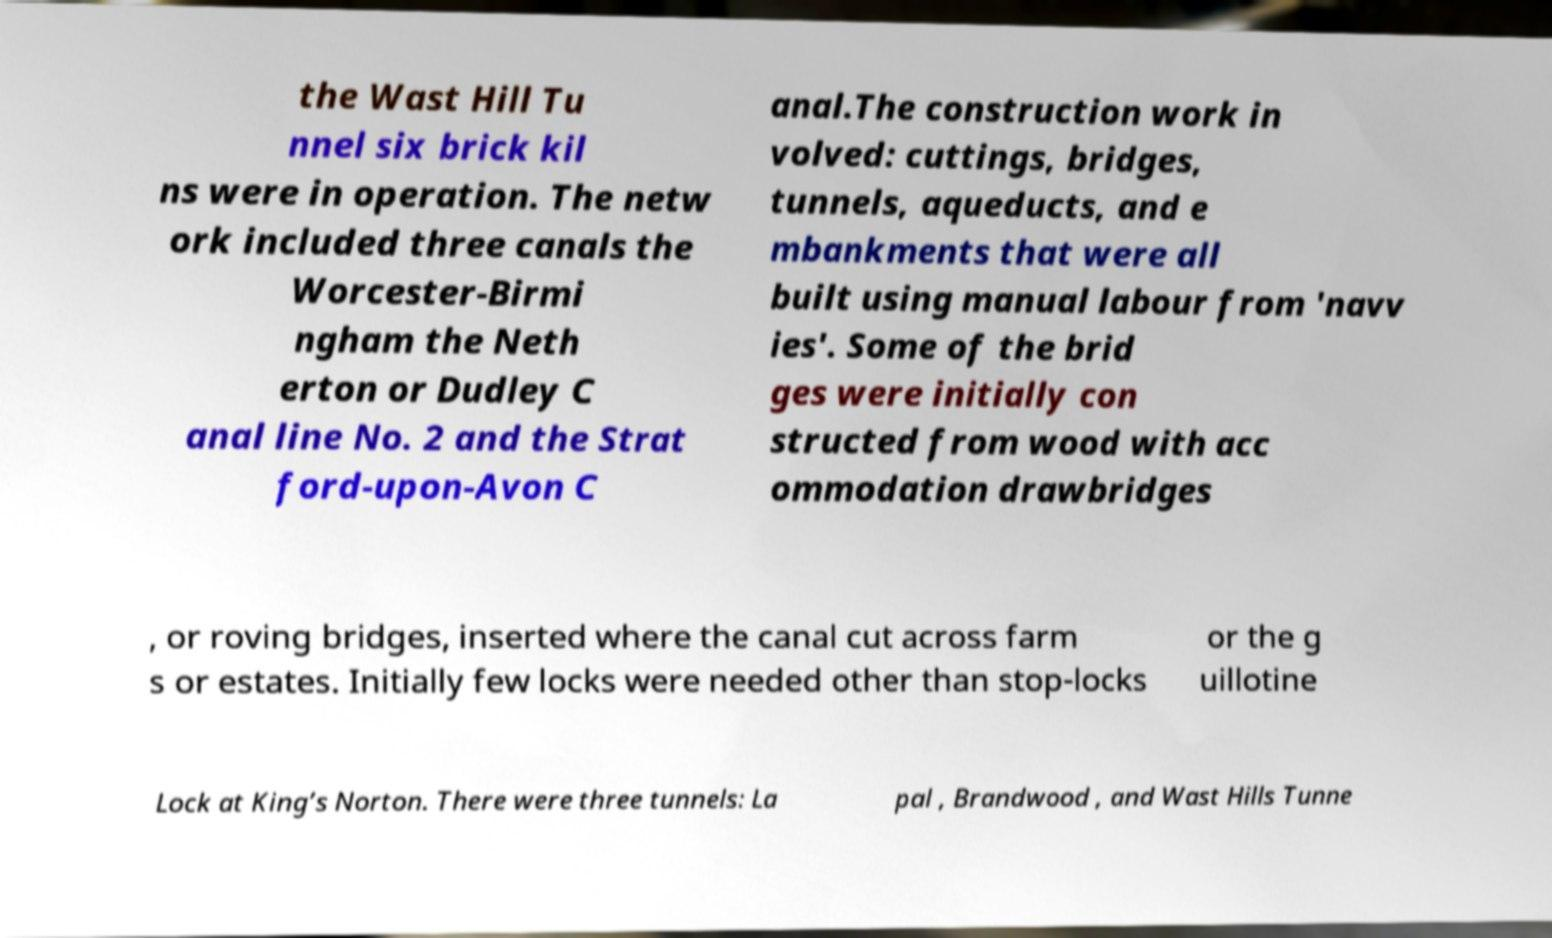Please read and relay the text visible in this image. What does it say? the Wast Hill Tu nnel six brick kil ns were in operation. The netw ork included three canals the Worcester-Birmi ngham the Neth erton or Dudley C anal line No. 2 and the Strat ford-upon-Avon C anal.The construction work in volved: cuttings, bridges, tunnels, aqueducts, and e mbankments that were all built using manual labour from 'navv ies'. Some of the brid ges were initially con structed from wood with acc ommodation drawbridges , or roving bridges, inserted where the canal cut across farm s or estates. Initially few locks were needed other than stop-locks or the g uillotine Lock at King’s Norton. There were three tunnels: La pal , Brandwood , and Wast Hills Tunne 